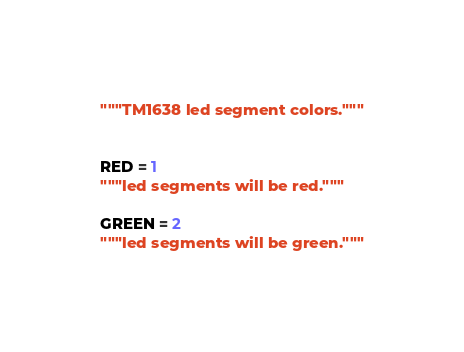Convert code to text. <code><loc_0><loc_0><loc_500><loc_500><_Python_>"""TM1638 led segment colors."""


RED = 1
"""led segments will be red."""

GREEN = 2
"""led segments will be green."""
</code> 